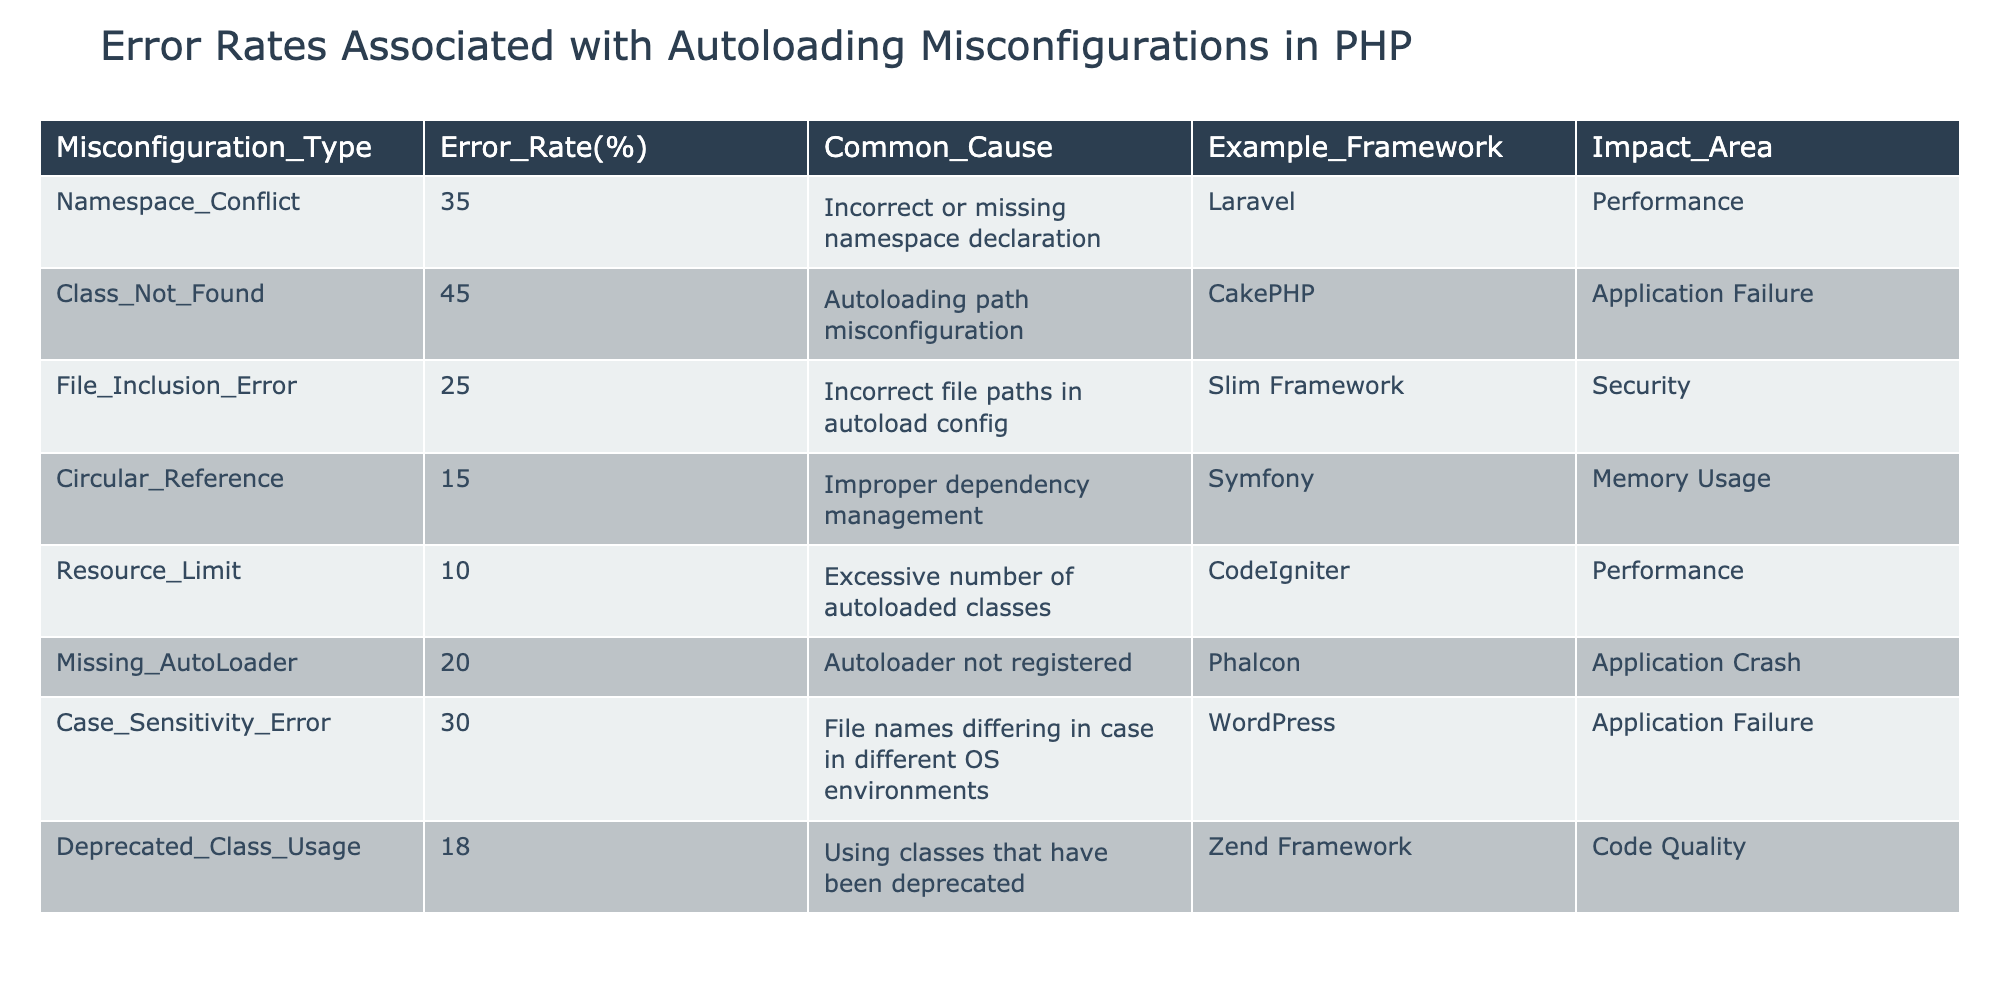What is the error rate for Class Not Found misconfigurations? The table indicates that the error rate for Class Not Found misconfigurations is specified under the Error Rate(%) column corresponding to that type. Looking at the table, it shows 45%.
Answer: 45% Which misconfiguration has the lowest error rate? By examining the Error Rate(%) column for all misconfiguration types, we can identify the minimum value. The lowest error rate is 10% for Resource Limit.
Answer: 10% How many misconfiguration types have an error rate greater than 20%? From the table, we count the misconfiguration types where the Error Rate(%) is more than 20. The misconfigurations Namespace Conflict, Class Not Found, Case Sensitivity Error, and Missing AutoLoader are greater than 20%, making it four in total.
Answer: 4 What is the impact area associated with the File Inclusion Error? The impact area for File Inclusion Error can be found in the corresponding row. According to the table, it affects Security.
Answer: Security Which two misconfigurations have the same impact area, and what is their error rate? We need to look for misconfigurations with the same impact area. From the table, both Class Not Found and Case Sensitivity Error lead to Application Failure with error rates of 45% and 30%, respectively.
Answer: Class Not Found (45%), Case Sensitivity Error (30%) What is the average error rate of all listed misconfigurations? To find the average, we calculate the sum of all the error rates and divide by the number of misconfigurations. The total is 35 + 45 + 25 + 15 + 10 + 20 + 30 + 18 = 188. Dividing by 8 gives an average of 23.5%.
Answer: 23.5% Is Circular Reference the misconfiguration with the highest error rate? By checking the Error Rate(%) column, we find that the highest value is 45% for Class Not Found, which is more than Circular Reference's 15%. Therefore, this statement is false.
Answer: No What common cause is associated with the Deprecated Class Usage misconfiguration? Looking up the row for Deprecated Class Usage in the Common Cause column reveals that its common cause is using classes that have been deprecated.
Answer: Using classes that have been deprecated 